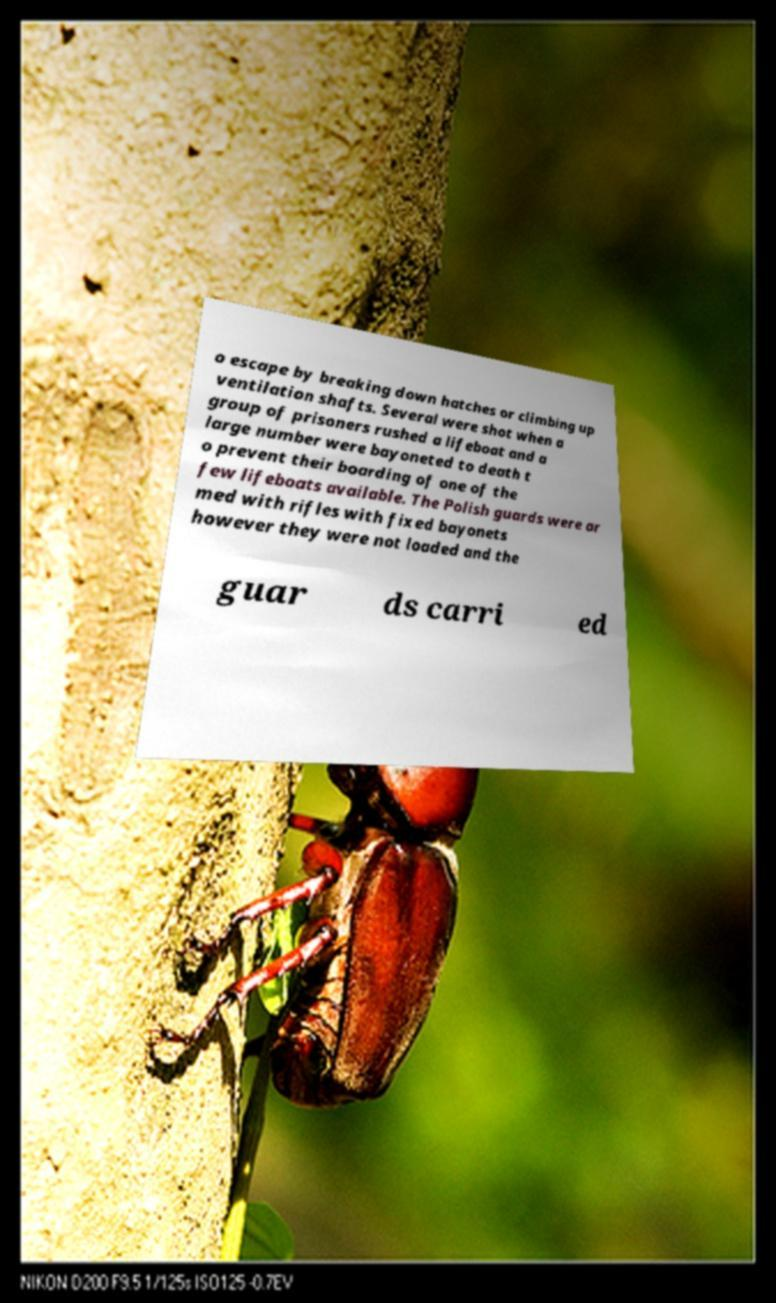Could you assist in decoding the text presented in this image and type it out clearly? o escape by breaking down hatches or climbing up ventilation shafts. Several were shot when a group of prisoners rushed a lifeboat and a large number were bayoneted to death t o prevent their boarding of one of the few lifeboats available. The Polish guards were ar med with rifles with fixed bayonets however they were not loaded and the guar ds carri ed 